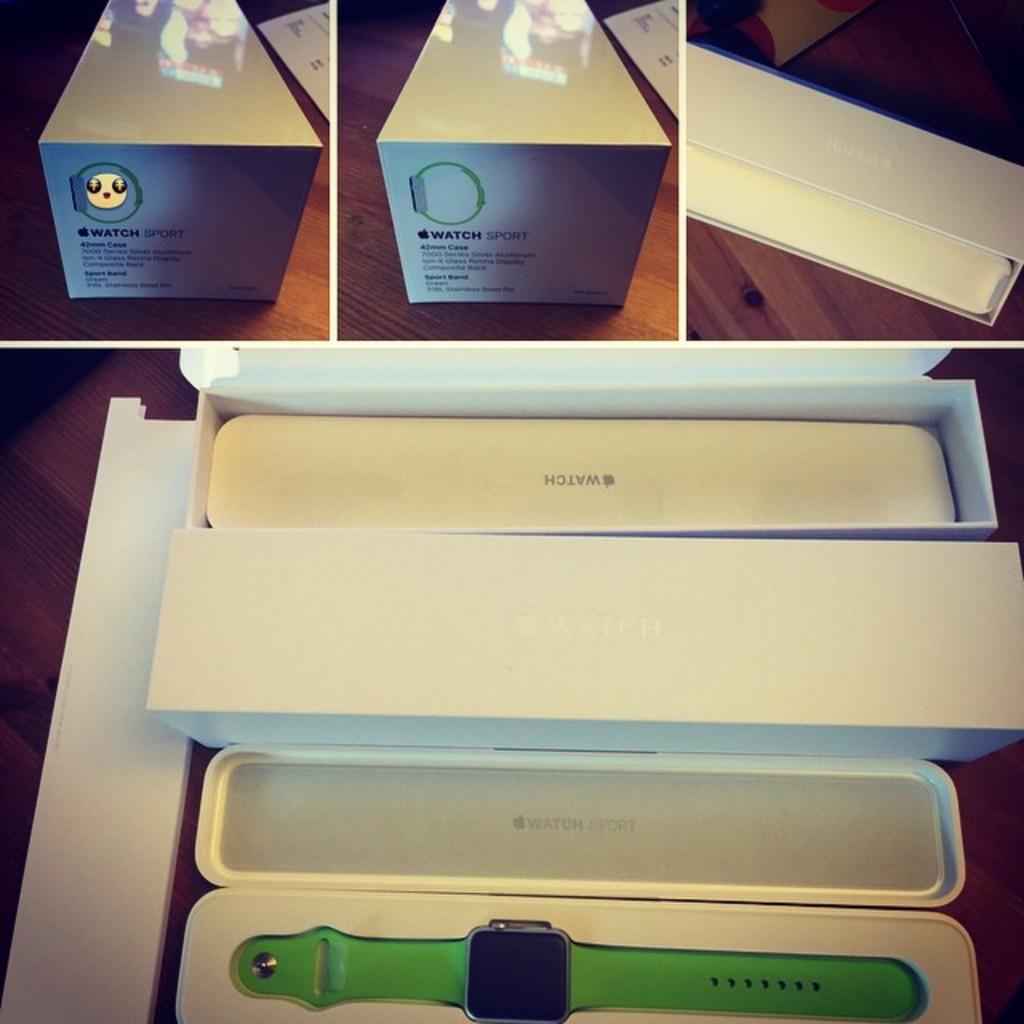What is the apple watch used for?
Your answer should be very brief. Unanswerable. What brand is this?
Your response must be concise. Apple. 